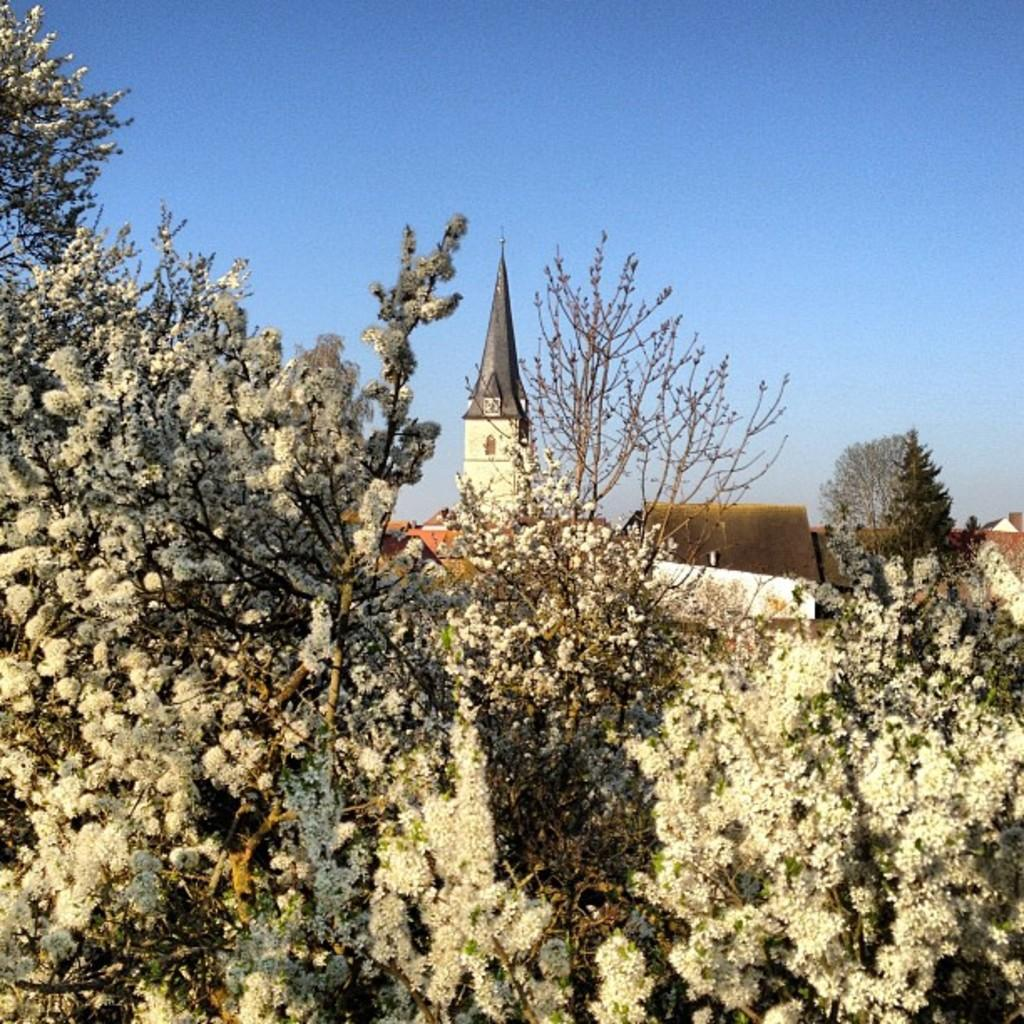What is the main subject in the center of the image? There are trees in the center of the image. What can be seen in the background of the image? There is a sky, buildings, a tower, additional trees, and other unspecified objects visible in the background. What type of poison is being used to cook the soup in the image? There is no soup or poison present in the image. 